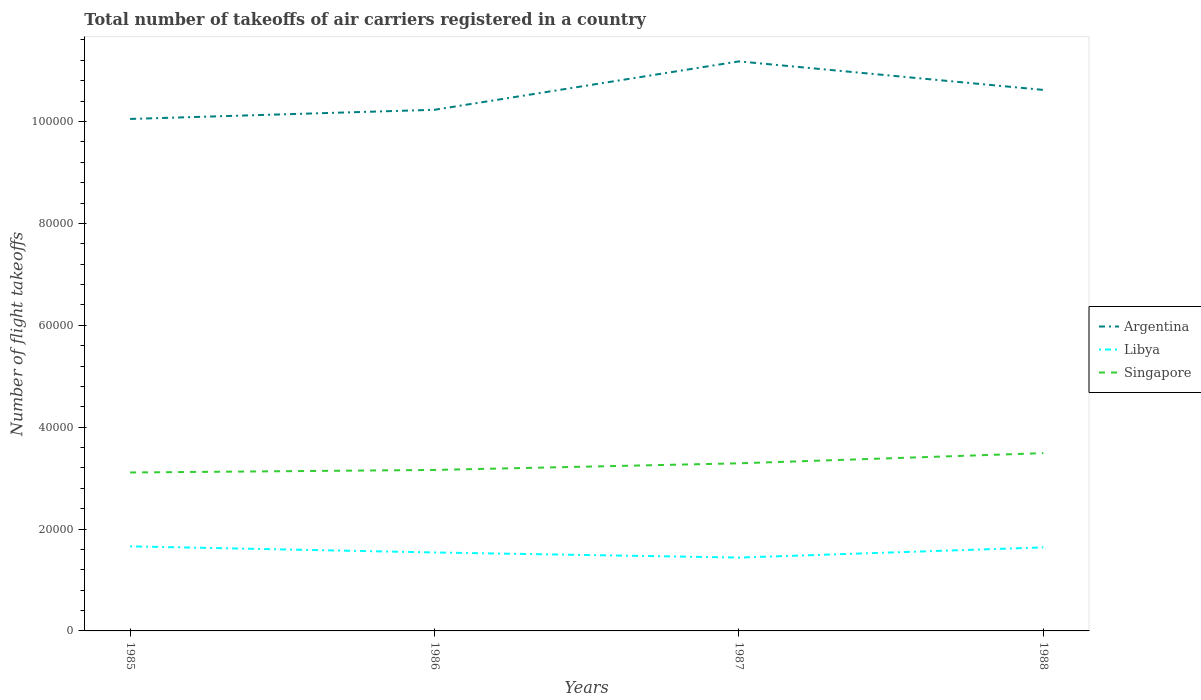Does the line corresponding to Singapore intersect with the line corresponding to Argentina?
Keep it short and to the point. No. Is the number of lines equal to the number of legend labels?
Provide a short and direct response. Yes. Across all years, what is the maximum total number of flight takeoffs in Argentina?
Provide a short and direct response. 1.00e+05. What is the total total number of flight takeoffs in Argentina in the graph?
Provide a short and direct response. 5600. What is the difference between the highest and the second highest total number of flight takeoffs in Argentina?
Offer a terse response. 1.13e+04. What is the difference between the highest and the lowest total number of flight takeoffs in Singapore?
Provide a short and direct response. 2. How many years are there in the graph?
Offer a very short reply. 4. Does the graph contain any zero values?
Provide a short and direct response. No. Where does the legend appear in the graph?
Your answer should be compact. Center right. What is the title of the graph?
Give a very brief answer. Total number of takeoffs of air carriers registered in a country. Does "Uzbekistan" appear as one of the legend labels in the graph?
Ensure brevity in your answer.  No. What is the label or title of the X-axis?
Ensure brevity in your answer.  Years. What is the label or title of the Y-axis?
Your answer should be compact. Number of flight takeoffs. What is the Number of flight takeoffs in Argentina in 1985?
Give a very brief answer. 1.00e+05. What is the Number of flight takeoffs of Libya in 1985?
Provide a short and direct response. 1.66e+04. What is the Number of flight takeoffs of Singapore in 1985?
Your answer should be very brief. 3.11e+04. What is the Number of flight takeoffs in Argentina in 1986?
Give a very brief answer. 1.02e+05. What is the Number of flight takeoffs in Libya in 1986?
Make the answer very short. 1.54e+04. What is the Number of flight takeoffs of Singapore in 1986?
Your response must be concise. 3.16e+04. What is the Number of flight takeoffs of Argentina in 1987?
Make the answer very short. 1.12e+05. What is the Number of flight takeoffs in Libya in 1987?
Your answer should be very brief. 1.44e+04. What is the Number of flight takeoffs in Singapore in 1987?
Ensure brevity in your answer.  3.29e+04. What is the Number of flight takeoffs in Argentina in 1988?
Offer a very short reply. 1.06e+05. What is the Number of flight takeoffs of Libya in 1988?
Provide a succinct answer. 1.64e+04. What is the Number of flight takeoffs in Singapore in 1988?
Provide a short and direct response. 3.49e+04. Across all years, what is the maximum Number of flight takeoffs of Argentina?
Ensure brevity in your answer.  1.12e+05. Across all years, what is the maximum Number of flight takeoffs of Libya?
Offer a terse response. 1.66e+04. Across all years, what is the maximum Number of flight takeoffs in Singapore?
Provide a succinct answer. 3.49e+04. Across all years, what is the minimum Number of flight takeoffs in Argentina?
Keep it short and to the point. 1.00e+05. Across all years, what is the minimum Number of flight takeoffs of Libya?
Keep it short and to the point. 1.44e+04. Across all years, what is the minimum Number of flight takeoffs in Singapore?
Provide a short and direct response. 3.11e+04. What is the total Number of flight takeoffs in Argentina in the graph?
Keep it short and to the point. 4.21e+05. What is the total Number of flight takeoffs of Libya in the graph?
Provide a succinct answer. 6.28e+04. What is the total Number of flight takeoffs in Singapore in the graph?
Your response must be concise. 1.30e+05. What is the difference between the Number of flight takeoffs of Argentina in 1985 and that in 1986?
Your answer should be compact. -1800. What is the difference between the Number of flight takeoffs in Libya in 1985 and that in 1986?
Offer a terse response. 1200. What is the difference between the Number of flight takeoffs of Singapore in 1985 and that in 1986?
Give a very brief answer. -500. What is the difference between the Number of flight takeoffs in Argentina in 1985 and that in 1987?
Offer a very short reply. -1.13e+04. What is the difference between the Number of flight takeoffs of Libya in 1985 and that in 1987?
Make the answer very short. 2200. What is the difference between the Number of flight takeoffs in Singapore in 1985 and that in 1987?
Provide a succinct answer. -1800. What is the difference between the Number of flight takeoffs of Argentina in 1985 and that in 1988?
Your answer should be very brief. -5700. What is the difference between the Number of flight takeoffs in Singapore in 1985 and that in 1988?
Ensure brevity in your answer.  -3800. What is the difference between the Number of flight takeoffs of Argentina in 1986 and that in 1987?
Give a very brief answer. -9500. What is the difference between the Number of flight takeoffs in Singapore in 1986 and that in 1987?
Provide a short and direct response. -1300. What is the difference between the Number of flight takeoffs in Argentina in 1986 and that in 1988?
Keep it short and to the point. -3900. What is the difference between the Number of flight takeoffs in Libya in 1986 and that in 1988?
Provide a succinct answer. -1000. What is the difference between the Number of flight takeoffs of Singapore in 1986 and that in 1988?
Provide a short and direct response. -3300. What is the difference between the Number of flight takeoffs of Argentina in 1987 and that in 1988?
Keep it short and to the point. 5600. What is the difference between the Number of flight takeoffs in Libya in 1987 and that in 1988?
Offer a very short reply. -2000. What is the difference between the Number of flight takeoffs of Singapore in 1987 and that in 1988?
Offer a terse response. -2000. What is the difference between the Number of flight takeoffs in Argentina in 1985 and the Number of flight takeoffs in Libya in 1986?
Provide a succinct answer. 8.51e+04. What is the difference between the Number of flight takeoffs of Argentina in 1985 and the Number of flight takeoffs of Singapore in 1986?
Your answer should be compact. 6.89e+04. What is the difference between the Number of flight takeoffs in Libya in 1985 and the Number of flight takeoffs in Singapore in 1986?
Give a very brief answer. -1.50e+04. What is the difference between the Number of flight takeoffs of Argentina in 1985 and the Number of flight takeoffs of Libya in 1987?
Your response must be concise. 8.61e+04. What is the difference between the Number of flight takeoffs of Argentina in 1985 and the Number of flight takeoffs of Singapore in 1987?
Your answer should be very brief. 6.76e+04. What is the difference between the Number of flight takeoffs of Libya in 1985 and the Number of flight takeoffs of Singapore in 1987?
Your answer should be very brief. -1.63e+04. What is the difference between the Number of flight takeoffs of Argentina in 1985 and the Number of flight takeoffs of Libya in 1988?
Make the answer very short. 8.41e+04. What is the difference between the Number of flight takeoffs of Argentina in 1985 and the Number of flight takeoffs of Singapore in 1988?
Keep it short and to the point. 6.56e+04. What is the difference between the Number of flight takeoffs of Libya in 1985 and the Number of flight takeoffs of Singapore in 1988?
Provide a short and direct response. -1.83e+04. What is the difference between the Number of flight takeoffs of Argentina in 1986 and the Number of flight takeoffs of Libya in 1987?
Provide a succinct answer. 8.79e+04. What is the difference between the Number of flight takeoffs in Argentina in 1986 and the Number of flight takeoffs in Singapore in 1987?
Keep it short and to the point. 6.94e+04. What is the difference between the Number of flight takeoffs in Libya in 1986 and the Number of flight takeoffs in Singapore in 1987?
Ensure brevity in your answer.  -1.75e+04. What is the difference between the Number of flight takeoffs in Argentina in 1986 and the Number of flight takeoffs in Libya in 1988?
Provide a succinct answer. 8.59e+04. What is the difference between the Number of flight takeoffs of Argentina in 1986 and the Number of flight takeoffs of Singapore in 1988?
Provide a short and direct response. 6.74e+04. What is the difference between the Number of flight takeoffs in Libya in 1986 and the Number of flight takeoffs in Singapore in 1988?
Provide a short and direct response. -1.95e+04. What is the difference between the Number of flight takeoffs of Argentina in 1987 and the Number of flight takeoffs of Libya in 1988?
Provide a short and direct response. 9.54e+04. What is the difference between the Number of flight takeoffs of Argentina in 1987 and the Number of flight takeoffs of Singapore in 1988?
Provide a succinct answer. 7.69e+04. What is the difference between the Number of flight takeoffs in Libya in 1987 and the Number of flight takeoffs in Singapore in 1988?
Offer a terse response. -2.05e+04. What is the average Number of flight takeoffs in Argentina per year?
Offer a terse response. 1.05e+05. What is the average Number of flight takeoffs of Libya per year?
Provide a short and direct response. 1.57e+04. What is the average Number of flight takeoffs in Singapore per year?
Give a very brief answer. 3.26e+04. In the year 1985, what is the difference between the Number of flight takeoffs in Argentina and Number of flight takeoffs in Libya?
Offer a terse response. 8.39e+04. In the year 1985, what is the difference between the Number of flight takeoffs of Argentina and Number of flight takeoffs of Singapore?
Your answer should be very brief. 6.94e+04. In the year 1985, what is the difference between the Number of flight takeoffs of Libya and Number of flight takeoffs of Singapore?
Ensure brevity in your answer.  -1.45e+04. In the year 1986, what is the difference between the Number of flight takeoffs in Argentina and Number of flight takeoffs in Libya?
Offer a very short reply. 8.69e+04. In the year 1986, what is the difference between the Number of flight takeoffs of Argentina and Number of flight takeoffs of Singapore?
Your response must be concise. 7.07e+04. In the year 1986, what is the difference between the Number of flight takeoffs in Libya and Number of flight takeoffs in Singapore?
Your answer should be very brief. -1.62e+04. In the year 1987, what is the difference between the Number of flight takeoffs in Argentina and Number of flight takeoffs in Libya?
Ensure brevity in your answer.  9.74e+04. In the year 1987, what is the difference between the Number of flight takeoffs of Argentina and Number of flight takeoffs of Singapore?
Offer a very short reply. 7.89e+04. In the year 1987, what is the difference between the Number of flight takeoffs of Libya and Number of flight takeoffs of Singapore?
Offer a very short reply. -1.85e+04. In the year 1988, what is the difference between the Number of flight takeoffs in Argentina and Number of flight takeoffs in Libya?
Offer a very short reply. 8.98e+04. In the year 1988, what is the difference between the Number of flight takeoffs of Argentina and Number of flight takeoffs of Singapore?
Offer a terse response. 7.13e+04. In the year 1988, what is the difference between the Number of flight takeoffs in Libya and Number of flight takeoffs in Singapore?
Provide a succinct answer. -1.85e+04. What is the ratio of the Number of flight takeoffs of Argentina in 1985 to that in 1986?
Keep it short and to the point. 0.98. What is the ratio of the Number of flight takeoffs in Libya in 1985 to that in 1986?
Give a very brief answer. 1.08. What is the ratio of the Number of flight takeoffs of Singapore in 1985 to that in 1986?
Give a very brief answer. 0.98. What is the ratio of the Number of flight takeoffs in Argentina in 1985 to that in 1987?
Your answer should be very brief. 0.9. What is the ratio of the Number of flight takeoffs in Libya in 1985 to that in 1987?
Keep it short and to the point. 1.15. What is the ratio of the Number of flight takeoffs in Singapore in 1985 to that in 1987?
Your answer should be compact. 0.95. What is the ratio of the Number of flight takeoffs in Argentina in 1985 to that in 1988?
Your response must be concise. 0.95. What is the ratio of the Number of flight takeoffs in Libya in 1985 to that in 1988?
Your answer should be very brief. 1.01. What is the ratio of the Number of flight takeoffs of Singapore in 1985 to that in 1988?
Make the answer very short. 0.89. What is the ratio of the Number of flight takeoffs in Argentina in 1986 to that in 1987?
Provide a succinct answer. 0.92. What is the ratio of the Number of flight takeoffs of Libya in 1986 to that in 1987?
Keep it short and to the point. 1.07. What is the ratio of the Number of flight takeoffs of Singapore in 1986 to that in 1987?
Offer a terse response. 0.96. What is the ratio of the Number of flight takeoffs of Argentina in 1986 to that in 1988?
Offer a terse response. 0.96. What is the ratio of the Number of flight takeoffs of Libya in 1986 to that in 1988?
Your answer should be very brief. 0.94. What is the ratio of the Number of flight takeoffs in Singapore in 1986 to that in 1988?
Offer a very short reply. 0.91. What is the ratio of the Number of flight takeoffs in Argentina in 1987 to that in 1988?
Ensure brevity in your answer.  1.05. What is the ratio of the Number of flight takeoffs in Libya in 1987 to that in 1988?
Your answer should be very brief. 0.88. What is the ratio of the Number of flight takeoffs of Singapore in 1987 to that in 1988?
Offer a terse response. 0.94. What is the difference between the highest and the second highest Number of flight takeoffs in Argentina?
Offer a terse response. 5600. What is the difference between the highest and the second highest Number of flight takeoffs in Libya?
Give a very brief answer. 200. What is the difference between the highest and the lowest Number of flight takeoffs in Argentina?
Offer a terse response. 1.13e+04. What is the difference between the highest and the lowest Number of flight takeoffs of Libya?
Keep it short and to the point. 2200. What is the difference between the highest and the lowest Number of flight takeoffs of Singapore?
Offer a terse response. 3800. 